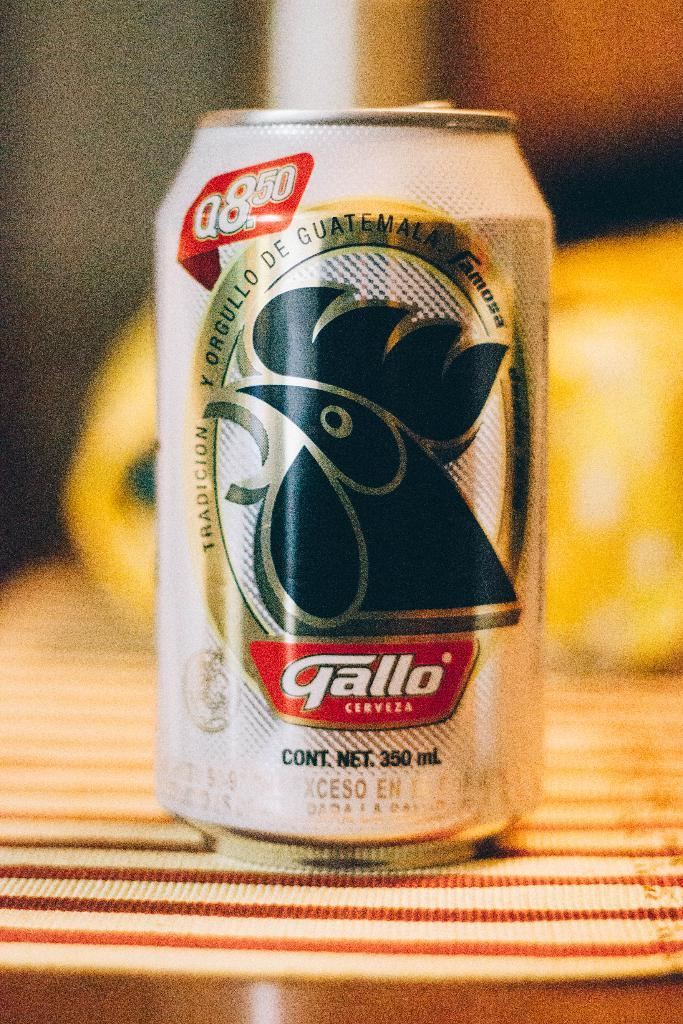What object is on the table in the image? There is a tin on the table in the image. Can you describe the background of the image? The background of the image is blurry. Is the tin swimming in the image? No, the tin is not swimming in the image; it is on the table. What type of street can be seen in the image? There is no street present in the image. 